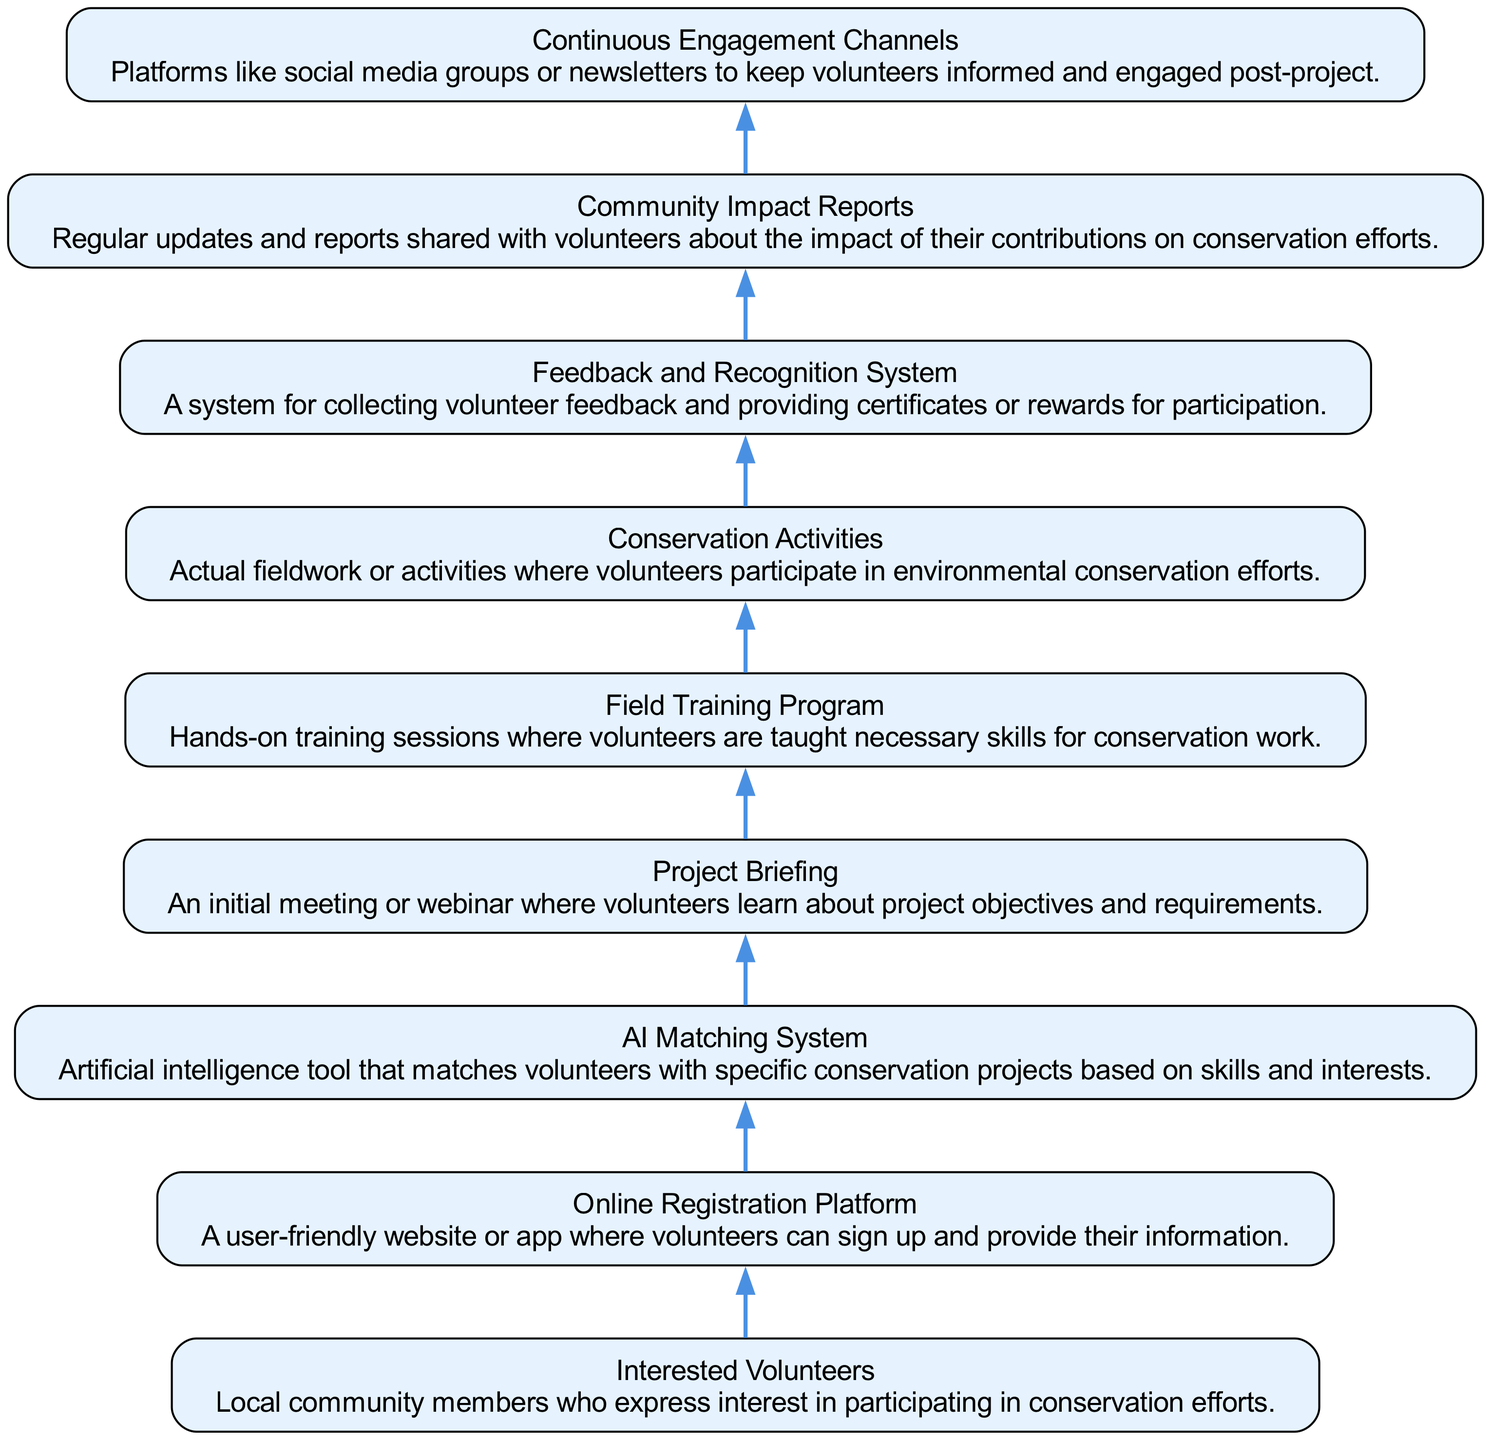What is the first node in the workflow? The diagram starts with "Interested Volunteers," which denotes the first group of individuals engaged in the process.
Answer: Interested Volunteers How many nodes are present in total? There are a total of nine nodes in the workflow, each representing a key component related to volunteer engagement.
Answer: 9 What is the last node in the flow? The flow ends with "Continuous Engagement Channels," which is the final component keeping volunteers connected after their projects.
Answer: Continuous Engagement Channels What links "Online Registration Platform" and "AI Matching System"? The edge that connects these two nodes indicates that volunteers register online before being matched to projects using AI, showing the sequential flow from registration to matching.
Answer: They are linked sequentially How many edges are in the workflow? The workflow comprises eight edges, connecting the nine nodes in a singular flow from "Interested Volunteers" to "Continuous Engagement Channels."
Answer: 8 Which node comes after "Field Training Program"? After completing the "Field Training Program," volunteers move to "Conservation Activities," demonstrating the progression from training to actual engagement.
Answer: Conservation Activities What description follows that of "AI Matching System"? The "AI Matching System" is described as the tool that matches volunteers based on skills and interests; the next description, for "Project Briefing," elaborates on the informational meeting volunteers will attend.
Answer: An initial meeting or webinar What role does "Feedback and Recognition System" play? This system is crucial as it collects feedback from volunteers and provides recognition through certificates or rewards for their contributions in conservation efforts.
Answer: Collects feedback and provides recognition What is the purpose of "Community Impact Reports"? Community Impact Reports serve to keep volunteers informed about the outcomes of their contributions, enhancing their connection to the projects and reinforcing the value of their work.
Answer: Shares updates on impact 